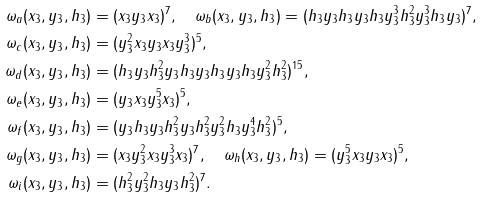Convert formula to latex. <formula><loc_0><loc_0><loc_500><loc_500>\omega _ { a } ( x _ { 3 } , y _ { 3 } , h _ { 3 } ) & = ( x _ { 3 } y _ { 3 } x _ { 3 } ) ^ { 7 } , \quad \omega _ { b } ( x _ { 3 } , y _ { 3 } , h _ { 3 } ) = ( h _ { 3 } y _ { 3 } h _ { 3 } y _ { 3 } h _ { 3 } y _ { 3 } ^ { 3 } h _ { 3 } ^ { 2 } y _ { 3 } ^ { 3 } h _ { 3 } y _ { 3 } ) ^ { 7 } , \\ \omega _ { c } ( x _ { 3 } , y _ { 3 } , h _ { 3 } ) & = ( y _ { 3 } ^ { 2 } x _ { 3 } y _ { 3 } x _ { 3 } y _ { 3 } ^ { 3 } ) ^ { 5 } , \\ \omega _ { d } ( x _ { 3 } , y _ { 3 } , h _ { 3 } ) & = ( h _ { 3 } y _ { 3 } h _ { 3 } ^ { 2 } y _ { 3 } h _ { 3 } y _ { 3 } h _ { 3 } y _ { 3 } h _ { 3 } y _ { 3 } ^ { 2 } h _ { 3 } ^ { 2 } ) ^ { 1 5 } , \\ \omega _ { e } ( x _ { 3 } , y _ { 3 } , h _ { 3 } ) & = ( y _ { 3 } x _ { 3 } y _ { 3 } ^ { 5 } x _ { 3 } ) ^ { 5 } , \\ \omega _ { f } ( x _ { 3 } , y _ { 3 } , h _ { 3 } ) & = ( y _ { 3 } h _ { 3 } y _ { 3 } h _ { 3 } ^ { 2 } y _ { 3 } h _ { 3 } ^ { 2 } y _ { 3 } ^ { 2 } h _ { 3 } y _ { 3 } ^ { 4 } h _ { 3 } ^ { 2 } ) ^ { 5 } , \\ \omega _ { g } ( x _ { 3 } , y _ { 3 } , h _ { 3 } ) & = ( x _ { 3 } y _ { 3 } ^ { 2 } x _ { 3 } y _ { 3 } ^ { 3 } x _ { 3 } ) ^ { 7 } , \quad \omega _ { h } ( x _ { 3 } , y _ { 3 } , h _ { 3 } ) = ( y _ { 3 } ^ { 5 } x _ { 3 } y _ { 3 } x _ { 3 } ) ^ { 5 } , \\ \omega _ { i } ( x _ { 3 } , y _ { 3 } , h _ { 3 } ) & = ( h _ { 3 } ^ { 2 } y _ { 3 } ^ { 2 } h _ { 3 } y _ { 3 } h _ { 3 } ^ { 2 } ) ^ { 7 } .</formula> 